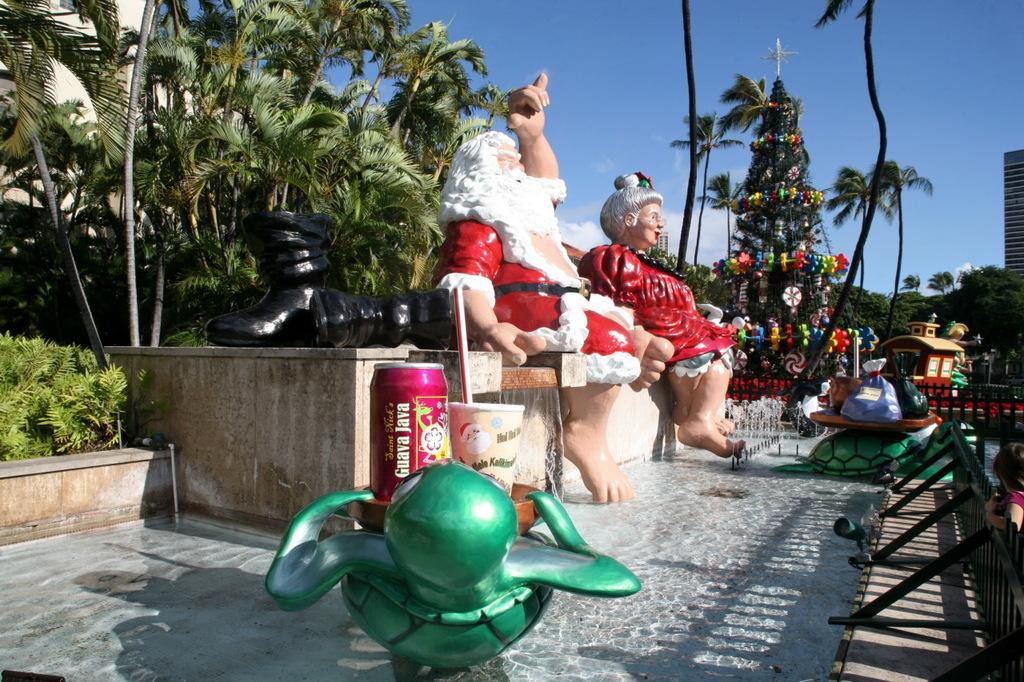What type of sculptures can be seen in the image? There are sculptures of a man and a woman in the image. What type of natural elements are present in the image? There are trees and plants in the image. What type of barrier is present in the image? There is a fence in the image. What else can be found on the ground in the image? There are other objects on the ground in the image. What is visible in the background of the image? The sky is visible in the background of the image. How many cans of soda are visible in the image? There are no cans of soda present in the image. What type of wind instrument is being played by the sculpture in the image? The sculptures in the image are not depicted playing any wind instruments. 